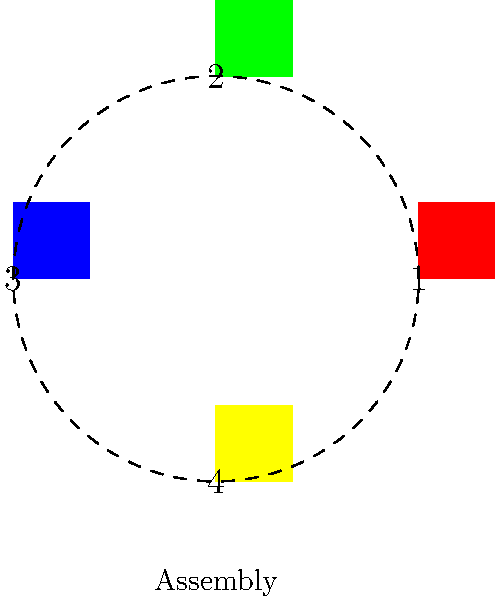Based on the diagram showing a multi-part 3D-printed object, what is the correct sequence for assembling the colored components to create a complete square? To determine the correct assembly sequence, we need to analyze the position and orientation of each colored component:

1. The red square (1) is positioned at the top.
2. The green square (2) is positioned on the right.
3. The blue square (3) is positioned at the bottom.
4. The yellow square (4) is positioned on the left.

To assemble these components into a complete square:

Step 1: Start with the bottom piece (blue, 3) as the base.
Step 2: Add the left piece (yellow, 4) to the left side of the base.
Step 3: Add the right piece (green, 2) to the right side of the base.
Step 4: Finally, place the top piece (red, 1) to complete the square.

Therefore, the correct assembly sequence is: 3 (blue), 4 (yellow), 2 (green), 1 (red).
Answer: 3, 4, 2, 1 